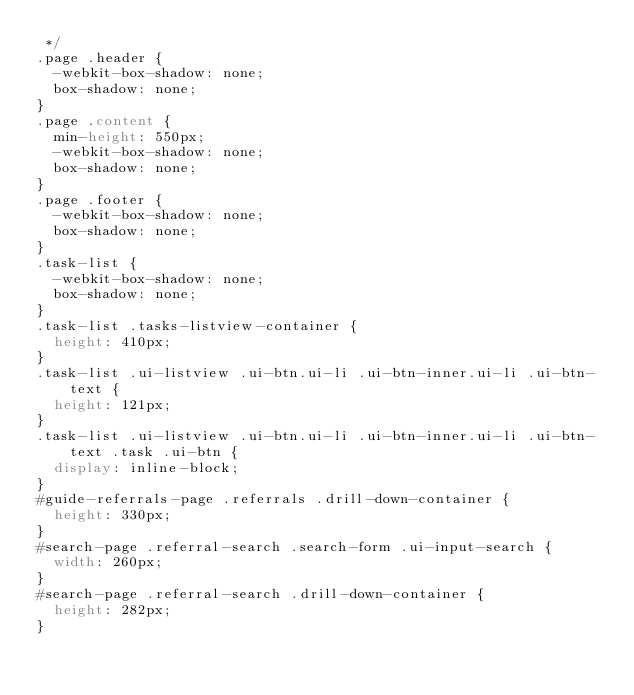<code> <loc_0><loc_0><loc_500><loc_500><_CSS_> */
.page .header {
  -webkit-box-shadow: none;
  box-shadow: none;
}
.page .content {
  min-height: 550px;
  -webkit-box-shadow: none;
  box-shadow: none;
}
.page .footer {
  -webkit-box-shadow: none;
  box-shadow: none;
}
.task-list {
  -webkit-box-shadow: none;
  box-shadow: none;
}
.task-list .tasks-listview-container {
  height: 410px;
}
.task-list .ui-listview .ui-btn.ui-li .ui-btn-inner.ui-li .ui-btn-text {
  height: 121px;
}
.task-list .ui-listview .ui-btn.ui-li .ui-btn-inner.ui-li .ui-btn-text .task .ui-btn {
  display: inline-block;
}
#guide-referrals-page .referrals .drill-down-container {
  height: 330px;
}
#search-page .referral-search .search-form .ui-input-search {
  width: 260px;
}
#search-page .referral-search .drill-down-container {
  height: 282px;
}
</code> 